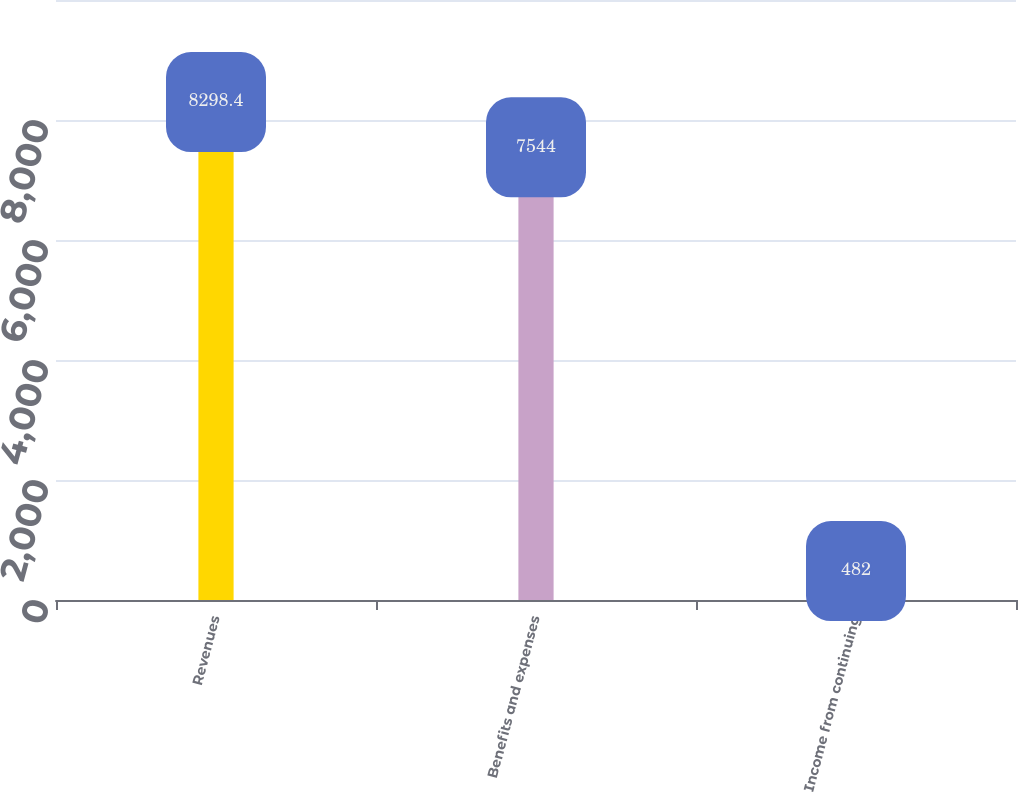<chart> <loc_0><loc_0><loc_500><loc_500><bar_chart><fcel>Revenues<fcel>Benefits and expenses<fcel>Income from continuing<nl><fcel>8298.4<fcel>7544<fcel>482<nl></chart> 